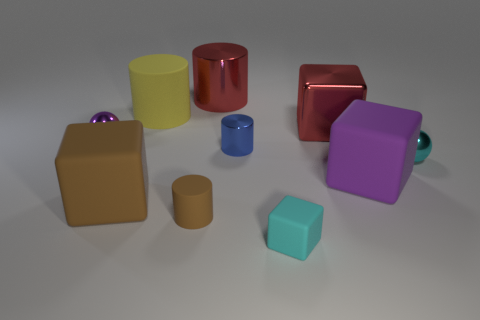There is a object that is the same color as the shiny block; what is its size?
Ensure brevity in your answer.  Large. Do the large matte cylinder and the shiny cylinder that is behind the tiny blue metal thing have the same color?
Offer a terse response. No. Is the small rubber cube the same color as the small matte cylinder?
Make the answer very short. No. How many other things are there of the same color as the large metallic cube?
Offer a terse response. 1. Are there fewer cyan rubber cubes that are to the left of the brown matte block than tiny things?
Keep it short and to the point. Yes. Are the big red object on the left side of the cyan rubber thing and the red cube made of the same material?
Your answer should be very brief. Yes. What is the shape of the small matte thing that is behind the small cyan object to the left of the object right of the purple block?
Give a very brief answer. Cylinder. Is there a brown shiny block of the same size as the cyan matte thing?
Provide a succinct answer. No. The blue metallic cylinder is what size?
Offer a very short reply. Small. What number of brown blocks have the same size as the cyan cube?
Your response must be concise. 0. 